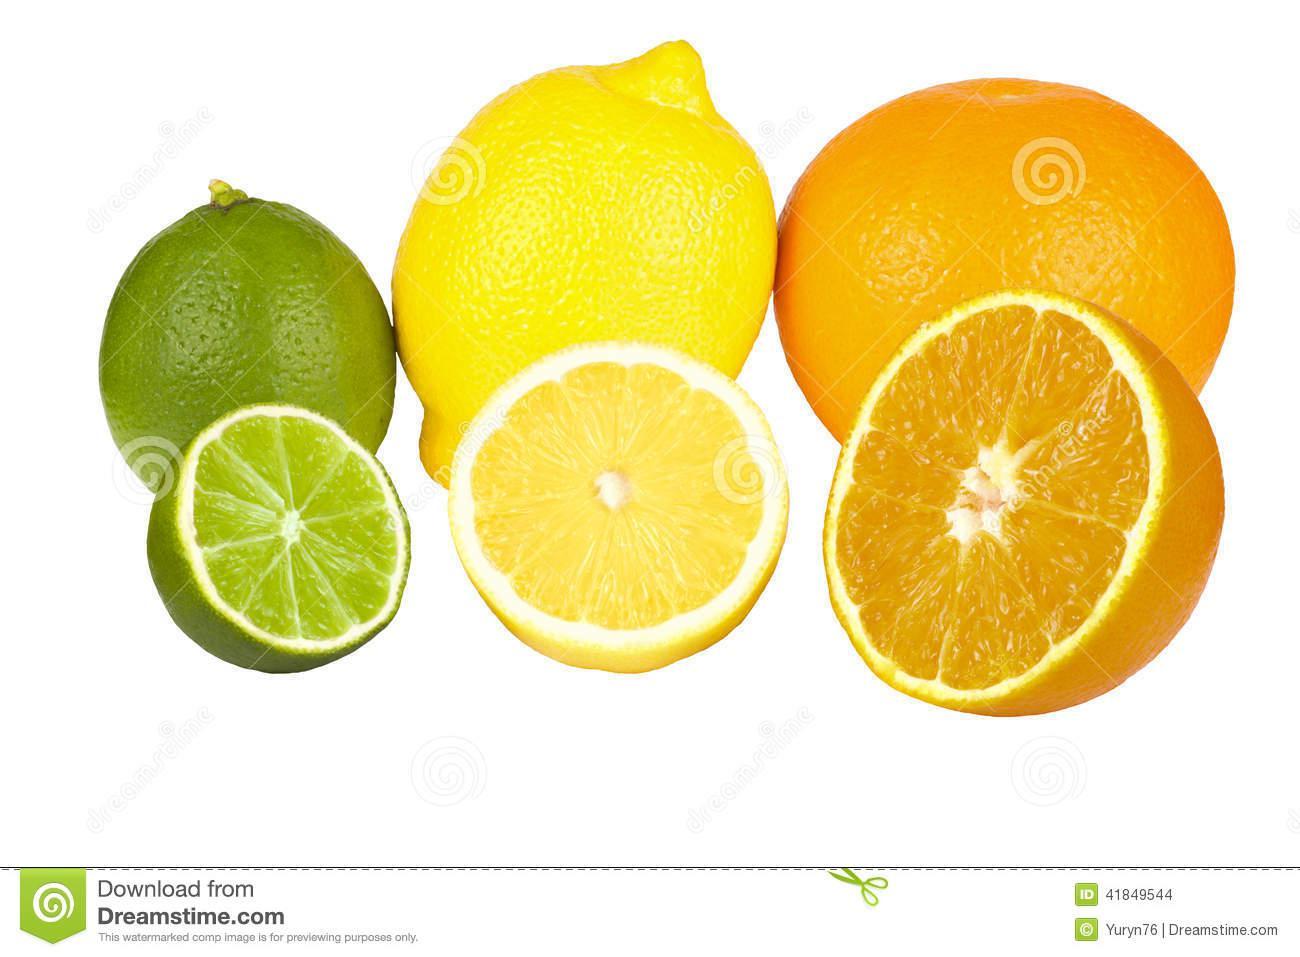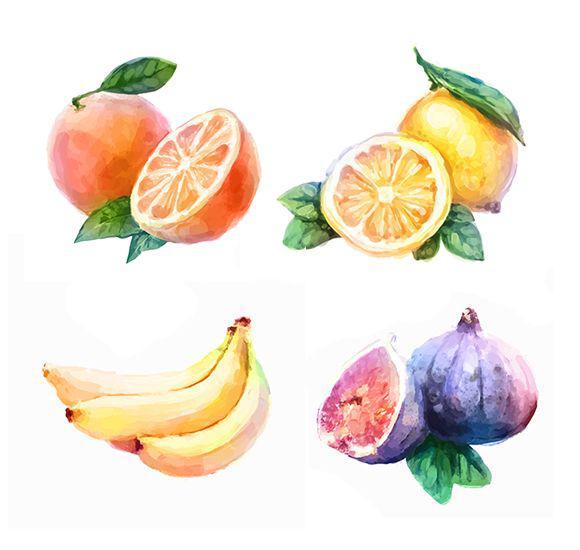The first image is the image on the left, the second image is the image on the right. For the images shown, is this caption "An image contains two intact peaches, plus a whole lemon next to part of a lemon." true? Answer yes or no. No. The first image is the image on the left, the second image is the image on the right. Considering the images on both sides, is "Exactly one fruit is sliced in half in one of the images." valid? Answer yes or no. No. 